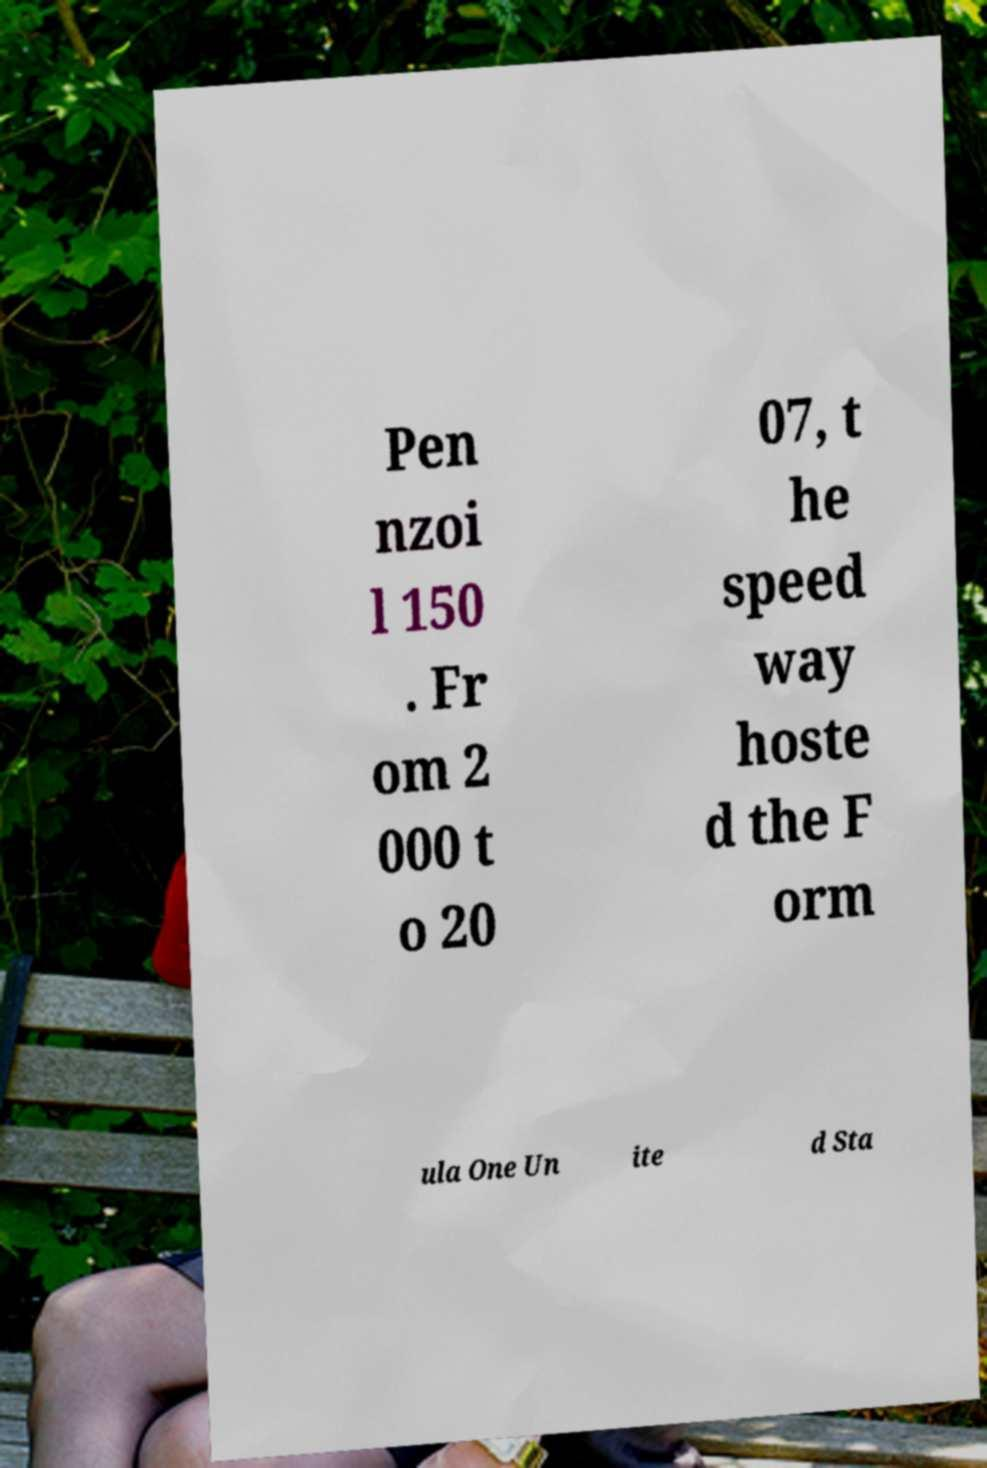What messages or text are displayed in this image? I need them in a readable, typed format. Pen nzoi l 150 . Fr om 2 000 t o 20 07, t he speed way hoste d the F orm ula One Un ite d Sta 